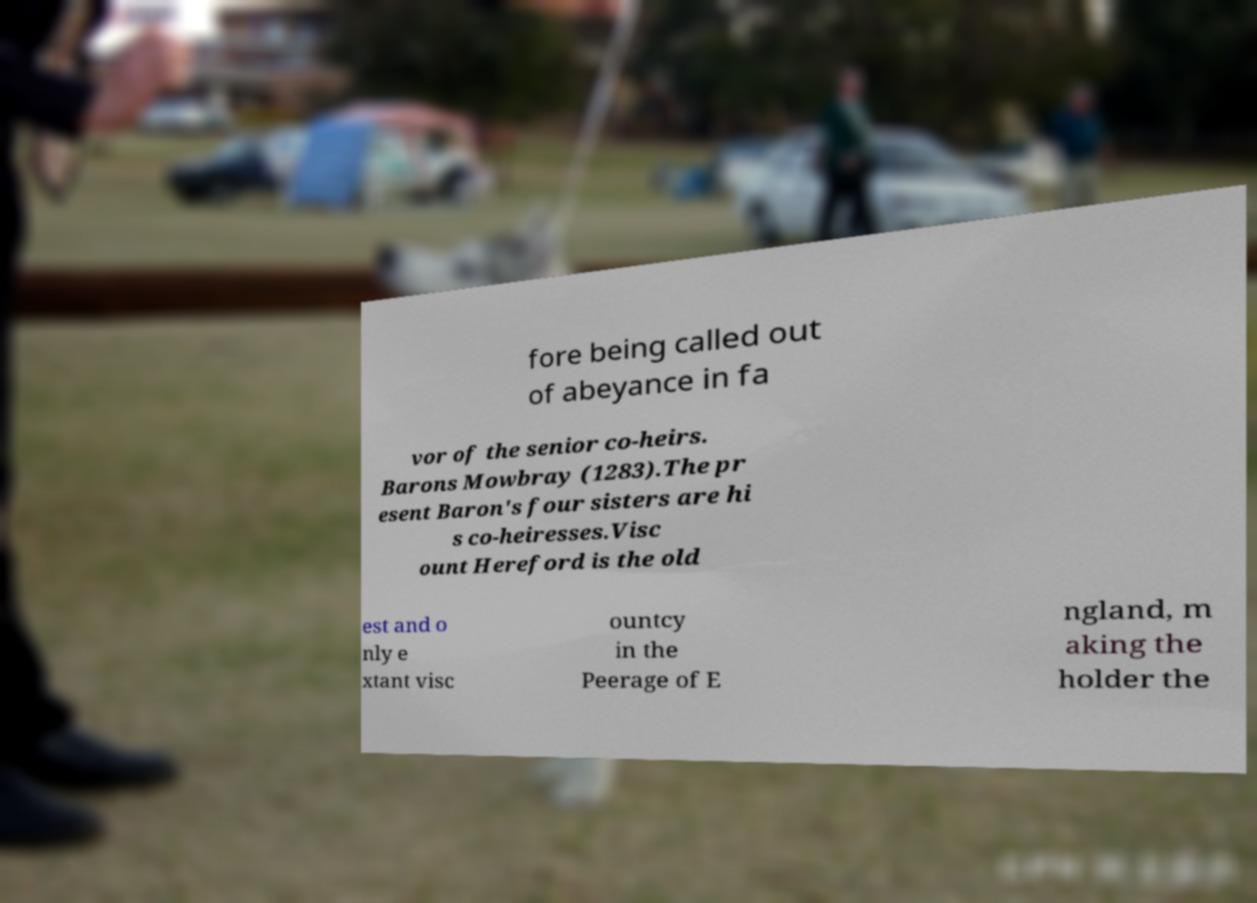Can you accurately transcribe the text from the provided image for me? fore being called out of abeyance in fa vor of the senior co-heirs. Barons Mowbray (1283).The pr esent Baron's four sisters are hi s co-heiresses.Visc ount Hereford is the old est and o nly e xtant visc ountcy in the Peerage of E ngland, m aking the holder the 